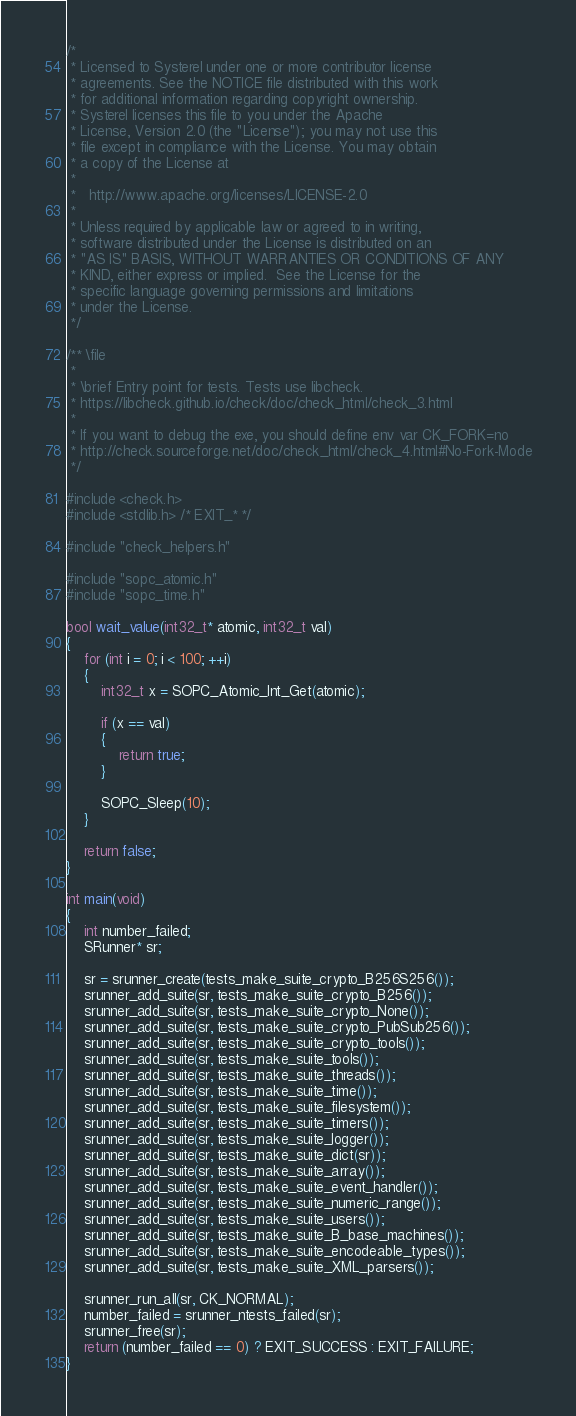<code> <loc_0><loc_0><loc_500><loc_500><_C_>/*
 * Licensed to Systerel under one or more contributor license
 * agreements. See the NOTICE file distributed with this work
 * for additional information regarding copyright ownership.
 * Systerel licenses this file to you under the Apache
 * License, Version 2.0 (the "License"); you may not use this
 * file except in compliance with the License. You may obtain
 * a copy of the License at
 *
 *   http://www.apache.org/licenses/LICENSE-2.0
 *
 * Unless required by applicable law or agreed to in writing,
 * software distributed under the License is distributed on an
 * "AS IS" BASIS, WITHOUT WARRANTIES OR CONDITIONS OF ANY
 * KIND, either express or implied.  See the License for the
 * specific language governing permissions and limitations
 * under the License.
 */

/** \file
 *
 * \brief Entry point for tests. Tests use libcheck.
 * https://libcheck.github.io/check/doc/check_html/check_3.html
 *
 * If you want to debug the exe, you should define env var CK_FORK=no
 * http://check.sourceforge.net/doc/check_html/check_4.html#No-Fork-Mode
 */

#include <check.h>
#include <stdlib.h> /* EXIT_* */

#include "check_helpers.h"

#include "sopc_atomic.h"
#include "sopc_time.h"

bool wait_value(int32_t* atomic, int32_t val)
{
    for (int i = 0; i < 100; ++i)
    {
        int32_t x = SOPC_Atomic_Int_Get(atomic);

        if (x == val)
        {
            return true;
        }

        SOPC_Sleep(10);
    }

    return false;
}

int main(void)
{
    int number_failed;
    SRunner* sr;

    sr = srunner_create(tests_make_suite_crypto_B256S256());
    srunner_add_suite(sr, tests_make_suite_crypto_B256());
    srunner_add_suite(sr, tests_make_suite_crypto_None());
    srunner_add_suite(sr, tests_make_suite_crypto_PubSub256());
    srunner_add_suite(sr, tests_make_suite_crypto_tools());
    srunner_add_suite(sr, tests_make_suite_tools());
    srunner_add_suite(sr, tests_make_suite_threads());
    srunner_add_suite(sr, tests_make_suite_time());
    srunner_add_suite(sr, tests_make_suite_filesystem());
    srunner_add_suite(sr, tests_make_suite_timers());
    srunner_add_suite(sr, tests_make_suite_logger());
    srunner_add_suite(sr, tests_make_suite_dict(sr));
    srunner_add_suite(sr, tests_make_suite_array());
    srunner_add_suite(sr, tests_make_suite_event_handler());
    srunner_add_suite(sr, tests_make_suite_numeric_range());
    srunner_add_suite(sr, tests_make_suite_users());
    srunner_add_suite(sr, tests_make_suite_B_base_machines());
    srunner_add_suite(sr, tests_make_suite_encodeable_types());
    srunner_add_suite(sr, tests_make_suite_XML_parsers());

    srunner_run_all(sr, CK_NORMAL);
    number_failed = srunner_ntests_failed(sr);
    srunner_free(sr);
    return (number_failed == 0) ? EXIT_SUCCESS : EXIT_FAILURE;
}
</code> 